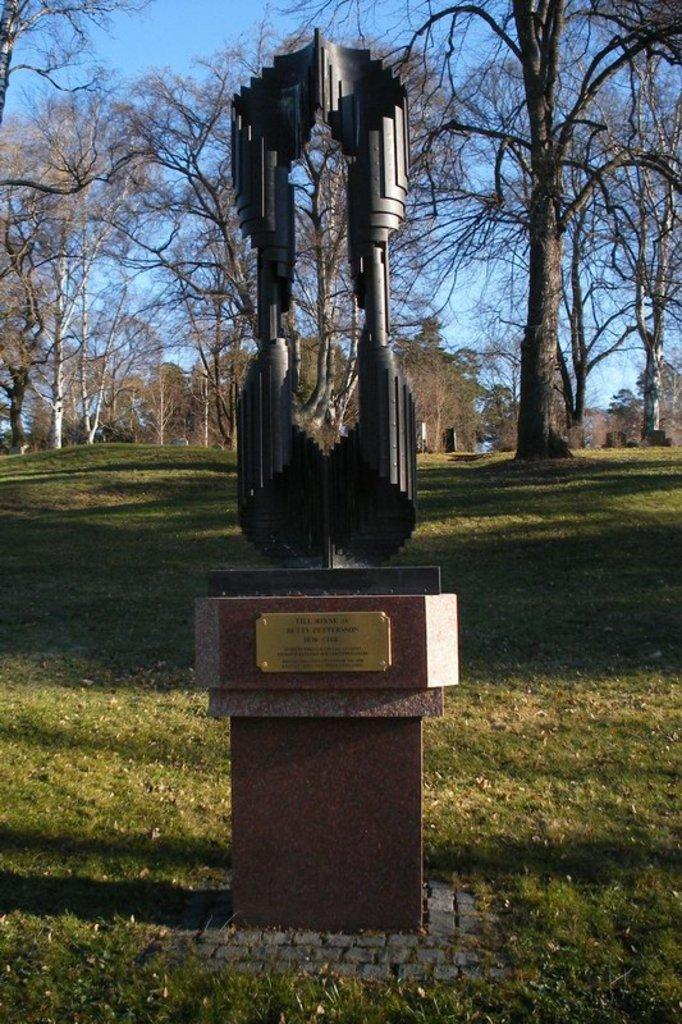What is the main subject in the image? There is a statue in the image. How is the statue positioned in the image? The statue is on a pedestal. What can be seen in the background of the image? There are trees and the sky visible in the background of the image. What degree does the statue have in the image? The statue is not a person and therefore cannot have a degree. --- Facts: 1. There is a car in the image. 2. The car is parked on the street. 3. There are buildings in the background of the image. 4. The sky is visible in the background of the image. Absurd Topics: dance, ocean, guitar Conversation: What is the main subject in the image? There is a car in the image. How is the car positioned in the image? The car is parked on the street. What can be seen in the background of the image? There are buildings and the sky visible in the background of the image. Reasoning: Let's think step by step in order to produce the conversation. We start by identifying the main subject in the image, which is the car. Then, we describe the car's positioning, noting that it is parked on the street. Finally, we mention the background elements, which include buildings and the sky. Each question is designed to elicit a specific detail about the image that is known from the provided facts. Absurd Question/Answer: Can you see the ocean in the background of the image? No, the image does not show the ocean; it shows a car parked on the street with buildings and the sky in the background. 